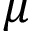Convert formula to latex. <formula><loc_0><loc_0><loc_500><loc_500>\mu</formula> 